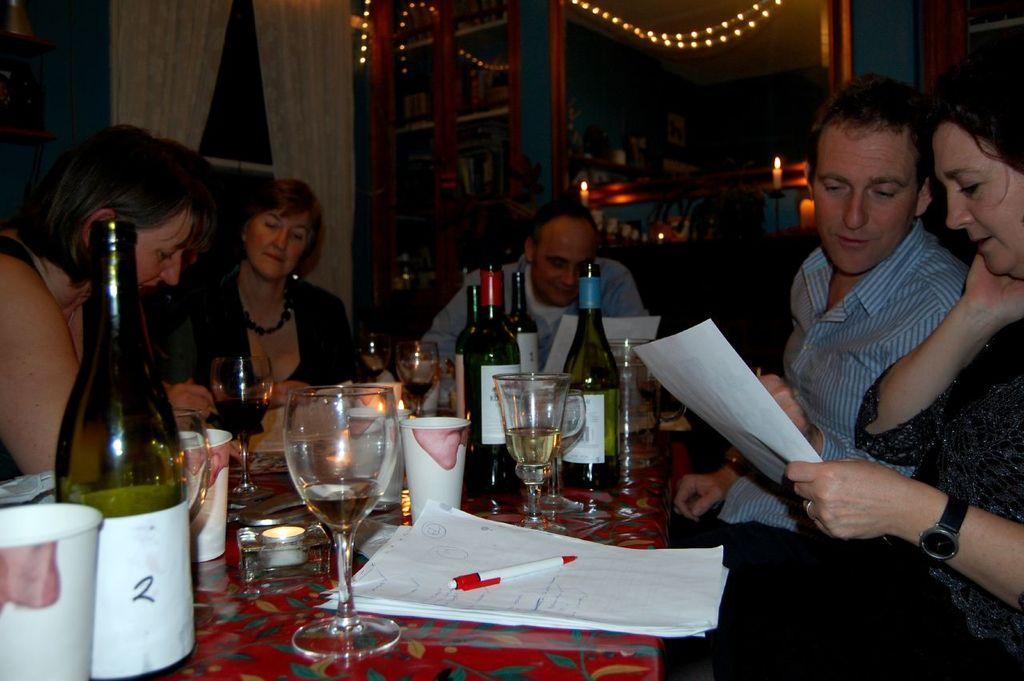Please provide a concise description of this image. This is a picture taken in a room, there are a group of people who are sitting on a chair in front of the people there is a table on the table there is a paper, pen, glass, cup, bottle and a ashtray. Background of this people is a shelf, curtain and the lights. 